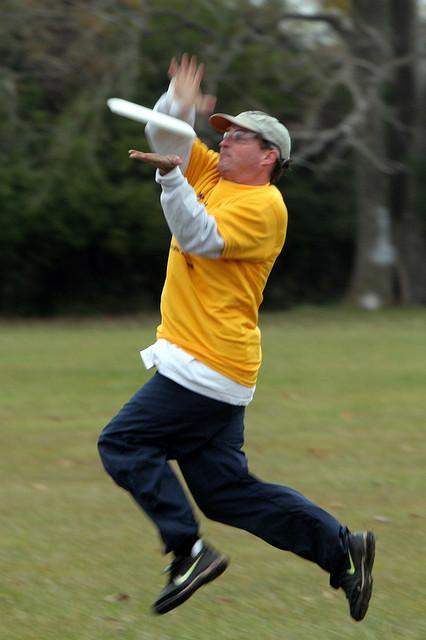What sport is this person playing?
Quick response, please. Frisbee. Where is the frisbee?
Give a very brief answer. Air. Is he good at this game?
Keep it brief. Yes. What sport does he play?
Answer briefly. Frisbee. 